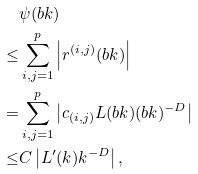<formula> <loc_0><loc_0><loc_500><loc_500>& \psi ( b k ) \\ \leq & \sum _ { i , j = 1 } ^ { p } \left | r ^ { ( i , j ) } ( b k ) \right | \\ = & \sum _ { i , j = 1 } ^ { p } \left | c _ { ( i , j ) } L ( b k ) ( b k ) ^ { - D } \right | \\ \leq & C \left | L ^ { \prime } ( k ) k ^ { - D } \right | ,</formula> 